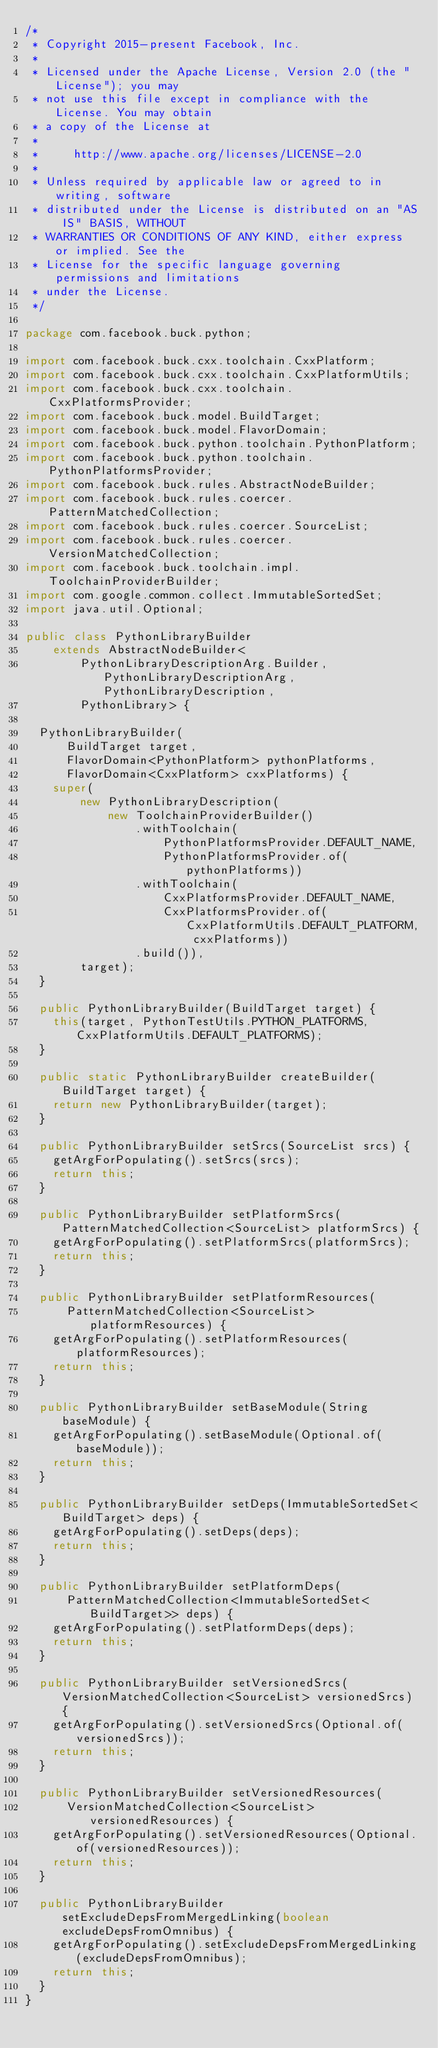Convert code to text. <code><loc_0><loc_0><loc_500><loc_500><_Java_>/*
 * Copyright 2015-present Facebook, Inc.
 *
 * Licensed under the Apache License, Version 2.0 (the "License"); you may
 * not use this file except in compliance with the License. You may obtain
 * a copy of the License at
 *
 *     http://www.apache.org/licenses/LICENSE-2.0
 *
 * Unless required by applicable law or agreed to in writing, software
 * distributed under the License is distributed on an "AS IS" BASIS, WITHOUT
 * WARRANTIES OR CONDITIONS OF ANY KIND, either express or implied. See the
 * License for the specific language governing permissions and limitations
 * under the License.
 */

package com.facebook.buck.python;

import com.facebook.buck.cxx.toolchain.CxxPlatform;
import com.facebook.buck.cxx.toolchain.CxxPlatformUtils;
import com.facebook.buck.cxx.toolchain.CxxPlatformsProvider;
import com.facebook.buck.model.BuildTarget;
import com.facebook.buck.model.FlavorDomain;
import com.facebook.buck.python.toolchain.PythonPlatform;
import com.facebook.buck.python.toolchain.PythonPlatformsProvider;
import com.facebook.buck.rules.AbstractNodeBuilder;
import com.facebook.buck.rules.coercer.PatternMatchedCollection;
import com.facebook.buck.rules.coercer.SourceList;
import com.facebook.buck.rules.coercer.VersionMatchedCollection;
import com.facebook.buck.toolchain.impl.ToolchainProviderBuilder;
import com.google.common.collect.ImmutableSortedSet;
import java.util.Optional;

public class PythonLibraryBuilder
    extends AbstractNodeBuilder<
        PythonLibraryDescriptionArg.Builder, PythonLibraryDescriptionArg, PythonLibraryDescription,
        PythonLibrary> {

  PythonLibraryBuilder(
      BuildTarget target,
      FlavorDomain<PythonPlatform> pythonPlatforms,
      FlavorDomain<CxxPlatform> cxxPlatforms) {
    super(
        new PythonLibraryDescription(
            new ToolchainProviderBuilder()
                .withToolchain(
                    PythonPlatformsProvider.DEFAULT_NAME,
                    PythonPlatformsProvider.of(pythonPlatforms))
                .withToolchain(
                    CxxPlatformsProvider.DEFAULT_NAME,
                    CxxPlatformsProvider.of(CxxPlatformUtils.DEFAULT_PLATFORM, cxxPlatforms))
                .build()),
        target);
  }

  public PythonLibraryBuilder(BuildTarget target) {
    this(target, PythonTestUtils.PYTHON_PLATFORMS, CxxPlatformUtils.DEFAULT_PLATFORMS);
  }

  public static PythonLibraryBuilder createBuilder(BuildTarget target) {
    return new PythonLibraryBuilder(target);
  }

  public PythonLibraryBuilder setSrcs(SourceList srcs) {
    getArgForPopulating().setSrcs(srcs);
    return this;
  }

  public PythonLibraryBuilder setPlatformSrcs(PatternMatchedCollection<SourceList> platformSrcs) {
    getArgForPopulating().setPlatformSrcs(platformSrcs);
    return this;
  }

  public PythonLibraryBuilder setPlatformResources(
      PatternMatchedCollection<SourceList> platformResources) {
    getArgForPopulating().setPlatformResources(platformResources);
    return this;
  }

  public PythonLibraryBuilder setBaseModule(String baseModule) {
    getArgForPopulating().setBaseModule(Optional.of(baseModule));
    return this;
  }

  public PythonLibraryBuilder setDeps(ImmutableSortedSet<BuildTarget> deps) {
    getArgForPopulating().setDeps(deps);
    return this;
  }

  public PythonLibraryBuilder setPlatformDeps(
      PatternMatchedCollection<ImmutableSortedSet<BuildTarget>> deps) {
    getArgForPopulating().setPlatformDeps(deps);
    return this;
  }

  public PythonLibraryBuilder setVersionedSrcs(VersionMatchedCollection<SourceList> versionedSrcs) {
    getArgForPopulating().setVersionedSrcs(Optional.of(versionedSrcs));
    return this;
  }

  public PythonLibraryBuilder setVersionedResources(
      VersionMatchedCollection<SourceList> versionedResources) {
    getArgForPopulating().setVersionedResources(Optional.of(versionedResources));
    return this;
  }

  public PythonLibraryBuilder setExcludeDepsFromMergedLinking(boolean excludeDepsFromOmnibus) {
    getArgForPopulating().setExcludeDepsFromMergedLinking(excludeDepsFromOmnibus);
    return this;
  }
}
</code> 